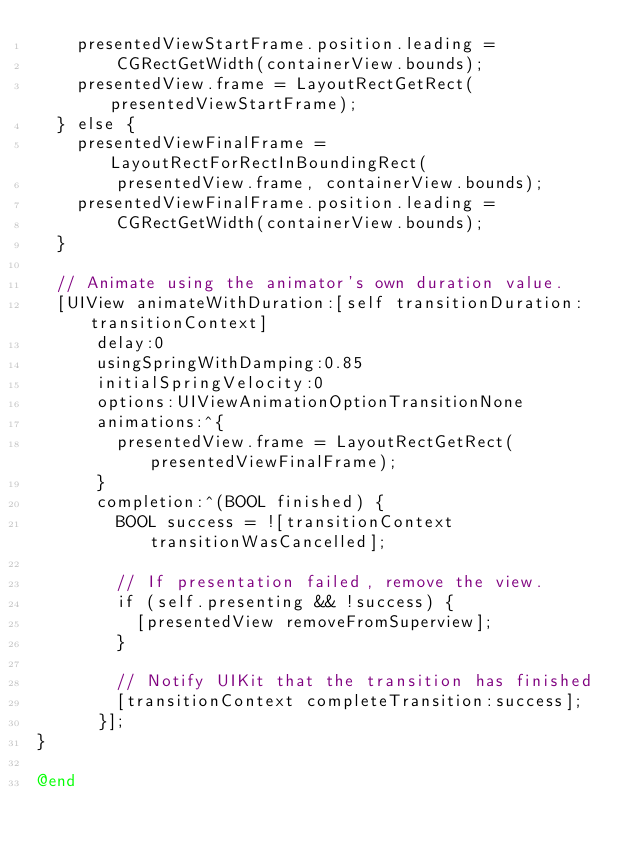<code> <loc_0><loc_0><loc_500><loc_500><_ObjectiveC_>    presentedViewStartFrame.position.leading =
        CGRectGetWidth(containerView.bounds);
    presentedView.frame = LayoutRectGetRect(presentedViewStartFrame);
  } else {
    presentedViewFinalFrame = LayoutRectForRectInBoundingRect(
        presentedView.frame, containerView.bounds);
    presentedViewFinalFrame.position.leading =
        CGRectGetWidth(containerView.bounds);
  }

  // Animate using the animator's own duration value.
  [UIView animateWithDuration:[self transitionDuration:transitionContext]
      delay:0
      usingSpringWithDamping:0.85
      initialSpringVelocity:0
      options:UIViewAnimationOptionTransitionNone
      animations:^{
        presentedView.frame = LayoutRectGetRect(presentedViewFinalFrame);
      }
      completion:^(BOOL finished) {
        BOOL success = ![transitionContext transitionWasCancelled];

        // If presentation failed, remove the view.
        if (self.presenting && !success) {
          [presentedView removeFromSuperview];
        }

        // Notify UIKit that the transition has finished
        [transitionContext completeTransition:success];
      }];
}

@end
</code> 